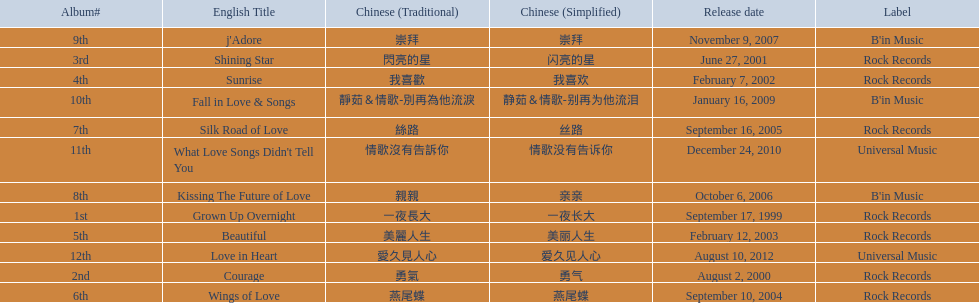Was the album beautiful released before the album love in heart? Yes. 